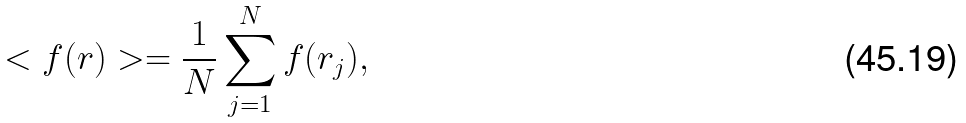<formula> <loc_0><loc_0><loc_500><loc_500>< f ( r ) > = \frac { 1 } { N } \sum _ { j = 1 } ^ { N } f ( r _ { j } ) ,</formula> 